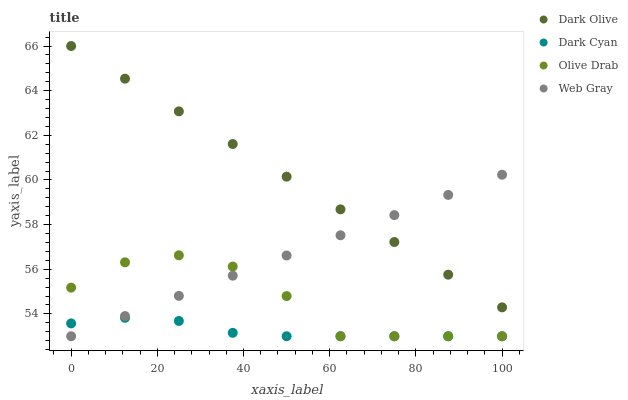Does Dark Cyan have the minimum area under the curve?
Answer yes or no. Yes. Does Dark Olive have the maximum area under the curve?
Answer yes or no. Yes. Does Web Gray have the minimum area under the curve?
Answer yes or no. No. Does Web Gray have the maximum area under the curve?
Answer yes or no. No. Is Web Gray the smoothest?
Answer yes or no. Yes. Is Olive Drab the roughest?
Answer yes or no. Yes. Is Dark Olive the smoothest?
Answer yes or no. No. Is Dark Olive the roughest?
Answer yes or no. No. Does Dark Cyan have the lowest value?
Answer yes or no. Yes. Does Dark Olive have the lowest value?
Answer yes or no. No. Does Dark Olive have the highest value?
Answer yes or no. Yes. Does Web Gray have the highest value?
Answer yes or no. No. Is Dark Cyan less than Dark Olive?
Answer yes or no. Yes. Is Dark Olive greater than Dark Cyan?
Answer yes or no. Yes. Does Dark Olive intersect Web Gray?
Answer yes or no. Yes. Is Dark Olive less than Web Gray?
Answer yes or no. No. Is Dark Olive greater than Web Gray?
Answer yes or no. No. Does Dark Cyan intersect Dark Olive?
Answer yes or no. No. 